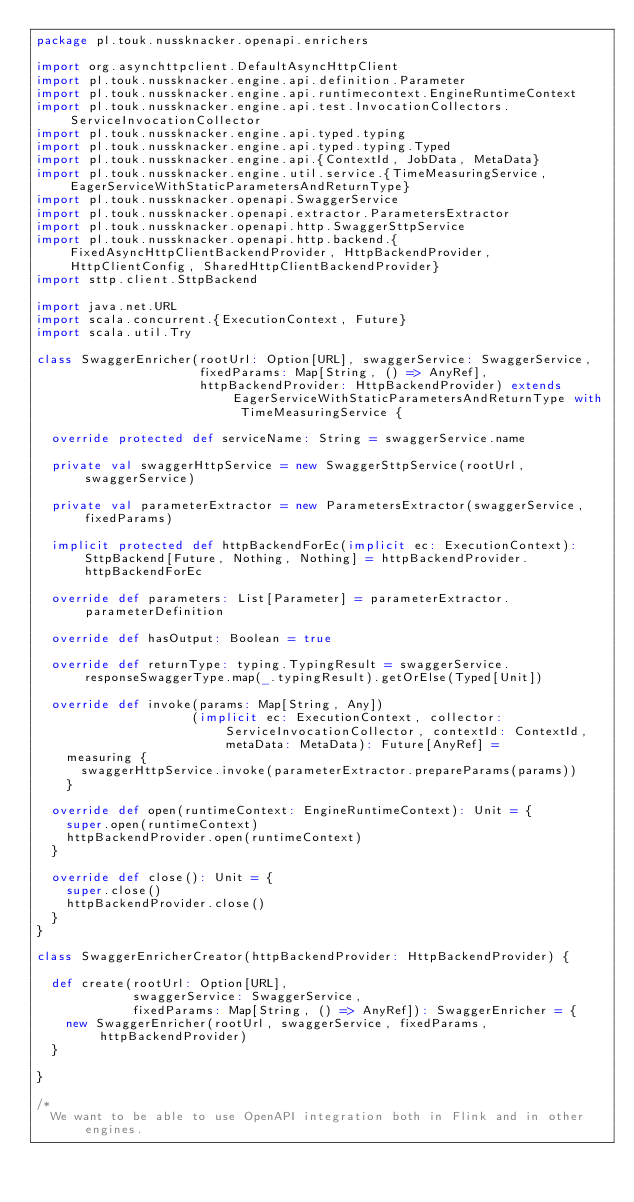<code> <loc_0><loc_0><loc_500><loc_500><_Scala_>package pl.touk.nussknacker.openapi.enrichers

import org.asynchttpclient.DefaultAsyncHttpClient
import pl.touk.nussknacker.engine.api.definition.Parameter
import pl.touk.nussknacker.engine.api.runtimecontext.EngineRuntimeContext
import pl.touk.nussknacker.engine.api.test.InvocationCollectors.ServiceInvocationCollector
import pl.touk.nussknacker.engine.api.typed.typing
import pl.touk.nussknacker.engine.api.typed.typing.Typed
import pl.touk.nussknacker.engine.api.{ContextId, JobData, MetaData}
import pl.touk.nussknacker.engine.util.service.{TimeMeasuringService, EagerServiceWithStaticParametersAndReturnType}
import pl.touk.nussknacker.openapi.SwaggerService
import pl.touk.nussknacker.openapi.extractor.ParametersExtractor
import pl.touk.nussknacker.openapi.http.SwaggerSttpService
import pl.touk.nussknacker.openapi.http.backend.{FixedAsyncHttpClientBackendProvider, HttpBackendProvider, HttpClientConfig, SharedHttpClientBackendProvider}
import sttp.client.SttpBackend

import java.net.URL
import scala.concurrent.{ExecutionContext, Future}
import scala.util.Try

class SwaggerEnricher(rootUrl: Option[URL], swaggerService: SwaggerService,
                      fixedParams: Map[String, () => AnyRef],
                      httpBackendProvider: HttpBackendProvider) extends EagerServiceWithStaticParametersAndReturnType with TimeMeasuringService {

  override protected def serviceName: String = swaggerService.name

  private val swaggerHttpService = new SwaggerSttpService(rootUrl, swaggerService)

  private val parameterExtractor = new ParametersExtractor(swaggerService, fixedParams)

  implicit protected def httpBackendForEc(implicit ec: ExecutionContext): SttpBackend[Future, Nothing, Nothing] = httpBackendProvider.httpBackendForEc

  override def parameters: List[Parameter] = parameterExtractor.parameterDefinition

  override def hasOutput: Boolean = true

  override def returnType: typing.TypingResult = swaggerService.responseSwaggerType.map(_.typingResult).getOrElse(Typed[Unit])

  override def invoke(params: Map[String, Any])
                     (implicit ec: ExecutionContext, collector: ServiceInvocationCollector, contextId: ContextId, metaData: MetaData): Future[AnyRef] =
    measuring {
      swaggerHttpService.invoke(parameterExtractor.prepareParams(params))
    }

  override def open(runtimeContext: EngineRuntimeContext): Unit = {
    super.open(runtimeContext)
    httpBackendProvider.open(runtimeContext)
  }

  override def close(): Unit = {
    super.close()
    httpBackendProvider.close()
  }
}

class SwaggerEnricherCreator(httpBackendProvider: HttpBackendProvider) {

  def create(rootUrl: Option[URL],
             swaggerService: SwaggerService,
             fixedParams: Map[String, () => AnyRef]): SwaggerEnricher = {
    new SwaggerEnricher(rootUrl, swaggerService, fixedParams, httpBackendProvider)
  }

}

/*
  We want to be able to use OpenAPI integration both in Flink and in other engines.</code> 